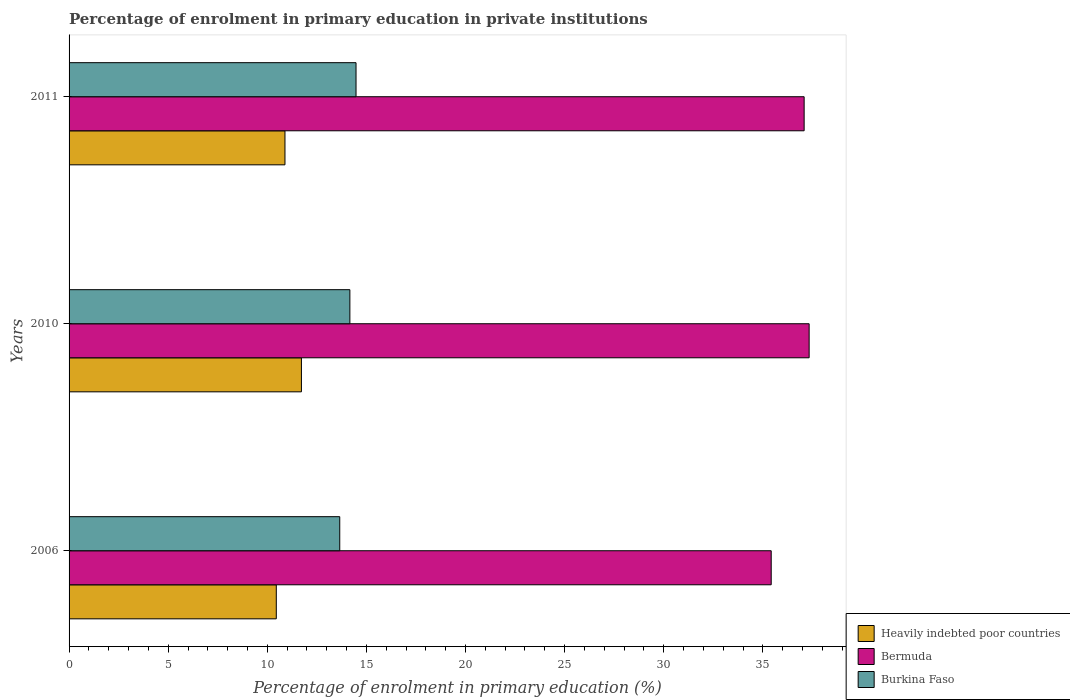How many different coloured bars are there?
Keep it short and to the point. 3. Are the number of bars per tick equal to the number of legend labels?
Your response must be concise. Yes. In how many cases, is the number of bars for a given year not equal to the number of legend labels?
Your answer should be compact. 0. What is the percentage of enrolment in primary education in Bermuda in 2006?
Provide a short and direct response. 35.42. Across all years, what is the maximum percentage of enrolment in primary education in Bermuda?
Keep it short and to the point. 37.34. Across all years, what is the minimum percentage of enrolment in primary education in Heavily indebted poor countries?
Make the answer very short. 10.45. In which year was the percentage of enrolment in primary education in Bermuda minimum?
Offer a terse response. 2006. What is the total percentage of enrolment in primary education in Burkina Faso in the graph?
Ensure brevity in your answer.  42.3. What is the difference between the percentage of enrolment in primary education in Burkina Faso in 2010 and that in 2011?
Provide a succinct answer. -0.31. What is the difference between the percentage of enrolment in primary education in Bermuda in 2010 and the percentage of enrolment in primary education in Heavily indebted poor countries in 2006?
Your answer should be very brief. 26.88. What is the average percentage of enrolment in primary education in Burkina Faso per year?
Ensure brevity in your answer.  14.1. In the year 2006, what is the difference between the percentage of enrolment in primary education in Burkina Faso and percentage of enrolment in primary education in Heavily indebted poor countries?
Your answer should be compact. 3.2. What is the ratio of the percentage of enrolment in primary education in Bermuda in 2006 to that in 2010?
Ensure brevity in your answer.  0.95. Is the percentage of enrolment in primary education in Bermuda in 2006 less than that in 2010?
Offer a very short reply. Yes. Is the difference between the percentage of enrolment in primary education in Burkina Faso in 2006 and 2011 greater than the difference between the percentage of enrolment in primary education in Heavily indebted poor countries in 2006 and 2011?
Offer a terse response. No. What is the difference between the highest and the second highest percentage of enrolment in primary education in Heavily indebted poor countries?
Offer a terse response. 0.83. What is the difference between the highest and the lowest percentage of enrolment in primary education in Heavily indebted poor countries?
Offer a terse response. 1.27. Is the sum of the percentage of enrolment in primary education in Burkina Faso in 2006 and 2010 greater than the maximum percentage of enrolment in primary education in Bermuda across all years?
Your answer should be compact. No. What does the 1st bar from the top in 2010 represents?
Provide a succinct answer. Burkina Faso. What does the 1st bar from the bottom in 2010 represents?
Offer a very short reply. Heavily indebted poor countries. How many years are there in the graph?
Keep it short and to the point. 3. Are the values on the major ticks of X-axis written in scientific E-notation?
Provide a short and direct response. No. How many legend labels are there?
Your answer should be compact. 3. What is the title of the graph?
Keep it short and to the point. Percentage of enrolment in primary education in private institutions. What is the label or title of the X-axis?
Provide a succinct answer. Percentage of enrolment in primary education (%). What is the label or title of the Y-axis?
Give a very brief answer. Years. What is the Percentage of enrolment in primary education (%) of Heavily indebted poor countries in 2006?
Provide a short and direct response. 10.45. What is the Percentage of enrolment in primary education (%) of Bermuda in 2006?
Provide a short and direct response. 35.42. What is the Percentage of enrolment in primary education (%) of Burkina Faso in 2006?
Keep it short and to the point. 13.66. What is the Percentage of enrolment in primary education (%) of Heavily indebted poor countries in 2010?
Offer a very short reply. 11.72. What is the Percentage of enrolment in primary education (%) in Bermuda in 2010?
Your answer should be compact. 37.34. What is the Percentage of enrolment in primary education (%) in Burkina Faso in 2010?
Offer a very short reply. 14.17. What is the Percentage of enrolment in primary education (%) in Heavily indebted poor countries in 2011?
Your answer should be compact. 10.89. What is the Percentage of enrolment in primary education (%) in Bermuda in 2011?
Make the answer very short. 37.08. What is the Percentage of enrolment in primary education (%) of Burkina Faso in 2011?
Provide a succinct answer. 14.48. Across all years, what is the maximum Percentage of enrolment in primary education (%) in Heavily indebted poor countries?
Provide a short and direct response. 11.72. Across all years, what is the maximum Percentage of enrolment in primary education (%) in Bermuda?
Offer a very short reply. 37.34. Across all years, what is the maximum Percentage of enrolment in primary education (%) in Burkina Faso?
Give a very brief answer. 14.48. Across all years, what is the minimum Percentage of enrolment in primary education (%) of Heavily indebted poor countries?
Provide a succinct answer. 10.45. Across all years, what is the minimum Percentage of enrolment in primary education (%) in Bermuda?
Your response must be concise. 35.42. Across all years, what is the minimum Percentage of enrolment in primary education (%) in Burkina Faso?
Offer a very short reply. 13.66. What is the total Percentage of enrolment in primary education (%) in Heavily indebted poor countries in the graph?
Give a very brief answer. 33.07. What is the total Percentage of enrolment in primary education (%) in Bermuda in the graph?
Make the answer very short. 109.84. What is the total Percentage of enrolment in primary education (%) of Burkina Faso in the graph?
Give a very brief answer. 42.3. What is the difference between the Percentage of enrolment in primary education (%) in Heavily indebted poor countries in 2006 and that in 2010?
Give a very brief answer. -1.27. What is the difference between the Percentage of enrolment in primary education (%) of Bermuda in 2006 and that in 2010?
Provide a succinct answer. -1.91. What is the difference between the Percentage of enrolment in primary education (%) of Burkina Faso in 2006 and that in 2010?
Your response must be concise. -0.51. What is the difference between the Percentage of enrolment in primary education (%) of Heavily indebted poor countries in 2006 and that in 2011?
Ensure brevity in your answer.  -0.44. What is the difference between the Percentage of enrolment in primary education (%) in Bermuda in 2006 and that in 2011?
Your answer should be very brief. -1.66. What is the difference between the Percentage of enrolment in primary education (%) of Burkina Faso in 2006 and that in 2011?
Provide a succinct answer. -0.82. What is the difference between the Percentage of enrolment in primary education (%) of Heavily indebted poor countries in 2010 and that in 2011?
Offer a very short reply. 0.83. What is the difference between the Percentage of enrolment in primary education (%) in Bermuda in 2010 and that in 2011?
Your answer should be very brief. 0.25. What is the difference between the Percentage of enrolment in primary education (%) of Burkina Faso in 2010 and that in 2011?
Offer a very short reply. -0.31. What is the difference between the Percentage of enrolment in primary education (%) in Heavily indebted poor countries in 2006 and the Percentage of enrolment in primary education (%) in Bermuda in 2010?
Offer a very short reply. -26.88. What is the difference between the Percentage of enrolment in primary education (%) of Heavily indebted poor countries in 2006 and the Percentage of enrolment in primary education (%) of Burkina Faso in 2010?
Make the answer very short. -3.71. What is the difference between the Percentage of enrolment in primary education (%) of Bermuda in 2006 and the Percentage of enrolment in primary education (%) of Burkina Faso in 2010?
Your answer should be very brief. 21.26. What is the difference between the Percentage of enrolment in primary education (%) of Heavily indebted poor countries in 2006 and the Percentage of enrolment in primary education (%) of Bermuda in 2011?
Ensure brevity in your answer.  -26.63. What is the difference between the Percentage of enrolment in primary education (%) of Heavily indebted poor countries in 2006 and the Percentage of enrolment in primary education (%) of Burkina Faso in 2011?
Keep it short and to the point. -4.02. What is the difference between the Percentage of enrolment in primary education (%) of Bermuda in 2006 and the Percentage of enrolment in primary education (%) of Burkina Faso in 2011?
Your answer should be very brief. 20.94. What is the difference between the Percentage of enrolment in primary education (%) in Heavily indebted poor countries in 2010 and the Percentage of enrolment in primary education (%) in Bermuda in 2011?
Offer a very short reply. -25.36. What is the difference between the Percentage of enrolment in primary education (%) of Heavily indebted poor countries in 2010 and the Percentage of enrolment in primary education (%) of Burkina Faso in 2011?
Make the answer very short. -2.76. What is the difference between the Percentage of enrolment in primary education (%) of Bermuda in 2010 and the Percentage of enrolment in primary education (%) of Burkina Faso in 2011?
Provide a succinct answer. 22.86. What is the average Percentage of enrolment in primary education (%) of Heavily indebted poor countries per year?
Offer a very short reply. 11.02. What is the average Percentage of enrolment in primary education (%) of Bermuda per year?
Offer a terse response. 36.61. What is the average Percentage of enrolment in primary education (%) of Burkina Faso per year?
Your response must be concise. 14.1. In the year 2006, what is the difference between the Percentage of enrolment in primary education (%) in Heavily indebted poor countries and Percentage of enrolment in primary education (%) in Bermuda?
Make the answer very short. -24.97. In the year 2006, what is the difference between the Percentage of enrolment in primary education (%) of Heavily indebted poor countries and Percentage of enrolment in primary education (%) of Burkina Faso?
Your response must be concise. -3.2. In the year 2006, what is the difference between the Percentage of enrolment in primary education (%) in Bermuda and Percentage of enrolment in primary education (%) in Burkina Faso?
Offer a terse response. 21.77. In the year 2010, what is the difference between the Percentage of enrolment in primary education (%) in Heavily indebted poor countries and Percentage of enrolment in primary education (%) in Bermuda?
Make the answer very short. -25.61. In the year 2010, what is the difference between the Percentage of enrolment in primary education (%) of Heavily indebted poor countries and Percentage of enrolment in primary education (%) of Burkina Faso?
Your answer should be very brief. -2.44. In the year 2010, what is the difference between the Percentage of enrolment in primary education (%) in Bermuda and Percentage of enrolment in primary education (%) in Burkina Faso?
Your response must be concise. 23.17. In the year 2011, what is the difference between the Percentage of enrolment in primary education (%) in Heavily indebted poor countries and Percentage of enrolment in primary education (%) in Bermuda?
Make the answer very short. -26.19. In the year 2011, what is the difference between the Percentage of enrolment in primary education (%) in Heavily indebted poor countries and Percentage of enrolment in primary education (%) in Burkina Faso?
Your answer should be compact. -3.58. In the year 2011, what is the difference between the Percentage of enrolment in primary education (%) in Bermuda and Percentage of enrolment in primary education (%) in Burkina Faso?
Your response must be concise. 22.61. What is the ratio of the Percentage of enrolment in primary education (%) in Heavily indebted poor countries in 2006 to that in 2010?
Provide a short and direct response. 0.89. What is the ratio of the Percentage of enrolment in primary education (%) of Bermuda in 2006 to that in 2010?
Your answer should be compact. 0.95. What is the ratio of the Percentage of enrolment in primary education (%) of Heavily indebted poor countries in 2006 to that in 2011?
Give a very brief answer. 0.96. What is the ratio of the Percentage of enrolment in primary education (%) in Bermuda in 2006 to that in 2011?
Provide a succinct answer. 0.96. What is the ratio of the Percentage of enrolment in primary education (%) in Burkina Faso in 2006 to that in 2011?
Keep it short and to the point. 0.94. What is the ratio of the Percentage of enrolment in primary education (%) in Heavily indebted poor countries in 2010 to that in 2011?
Give a very brief answer. 1.08. What is the ratio of the Percentage of enrolment in primary education (%) in Bermuda in 2010 to that in 2011?
Your answer should be very brief. 1.01. What is the ratio of the Percentage of enrolment in primary education (%) of Burkina Faso in 2010 to that in 2011?
Your answer should be compact. 0.98. What is the difference between the highest and the second highest Percentage of enrolment in primary education (%) in Heavily indebted poor countries?
Keep it short and to the point. 0.83. What is the difference between the highest and the second highest Percentage of enrolment in primary education (%) in Bermuda?
Provide a succinct answer. 0.25. What is the difference between the highest and the second highest Percentage of enrolment in primary education (%) in Burkina Faso?
Keep it short and to the point. 0.31. What is the difference between the highest and the lowest Percentage of enrolment in primary education (%) of Heavily indebted poor countries?
Ensure brevity in your answer.  1.27. What is the difference between the highest and the lowest Percentage of enrolment in primary education (%) of Bermuda?
Your answer should be compact. 1.91. What is the difference between the highest and the lowest Percentage of enrolment in primary education (%) of Burkina Faso?
Provide a short and direct response. 0.82. 